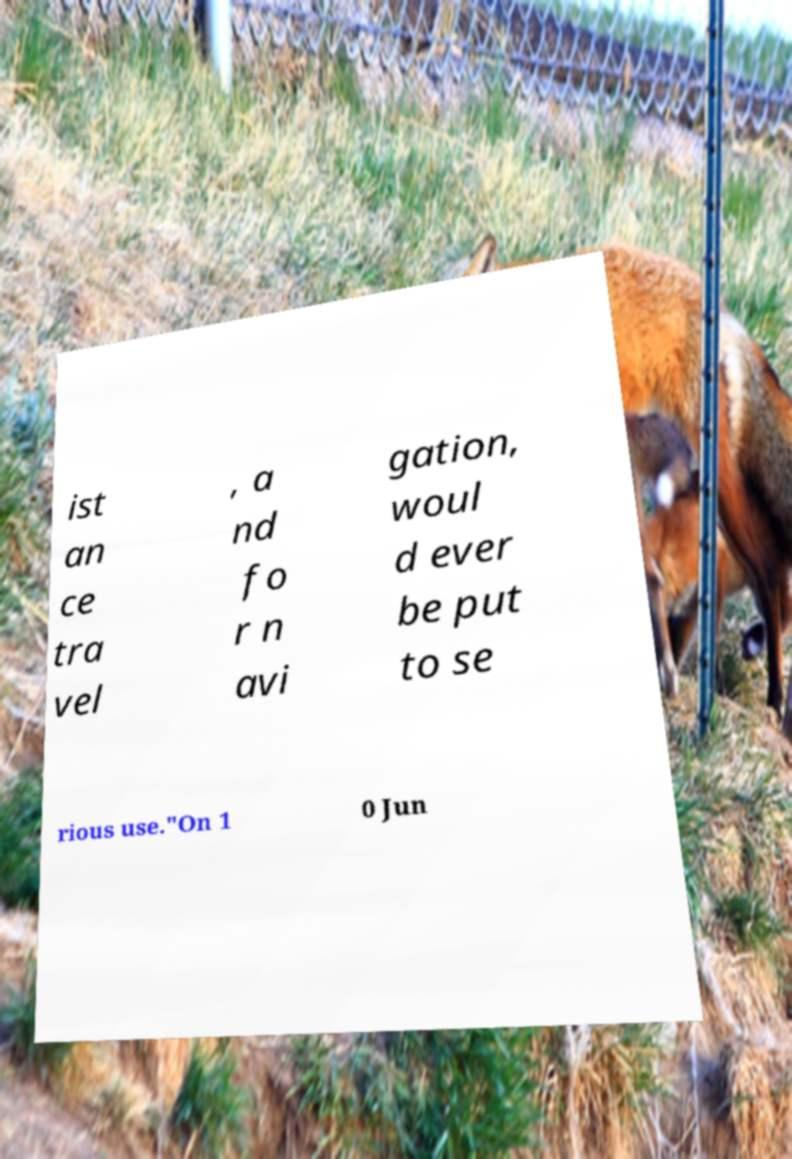There's text embedded in this image that I need extracted. Can you transcribe it verbatim? ist an ce tra vel , a nd fo r n avi gation, woul d ever be put to se rious use."On 1 0 Jun 